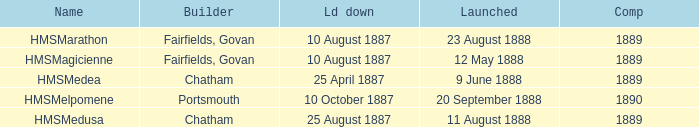Which builder completed before 1890 and launched on 9 june 1888? Chatham. Can you give me this table as a dict? {'header': ['Name', 'Builder', 'Ld down', 'Launched', 'Comp'], 'rows': [['HMSMarathon', 'Fairfields, Govan', '10 August 1887', '23 August 1888', '1889'], ['HMSMagicienne', 'Fairfields, Govan', '10 August 1887', '12 May 1888', '1889'], ['HMSMedea', 'Chatham', '25 April 1887', '9 June 1888', '1889'], ['HMSMelpomene', 'Portsmouth', '10 October 1887', '20 September 1888', '1890'], ['HMSMedusa', 'Chatham', '25 August 1887', '11 August 1888', '1889']]} 